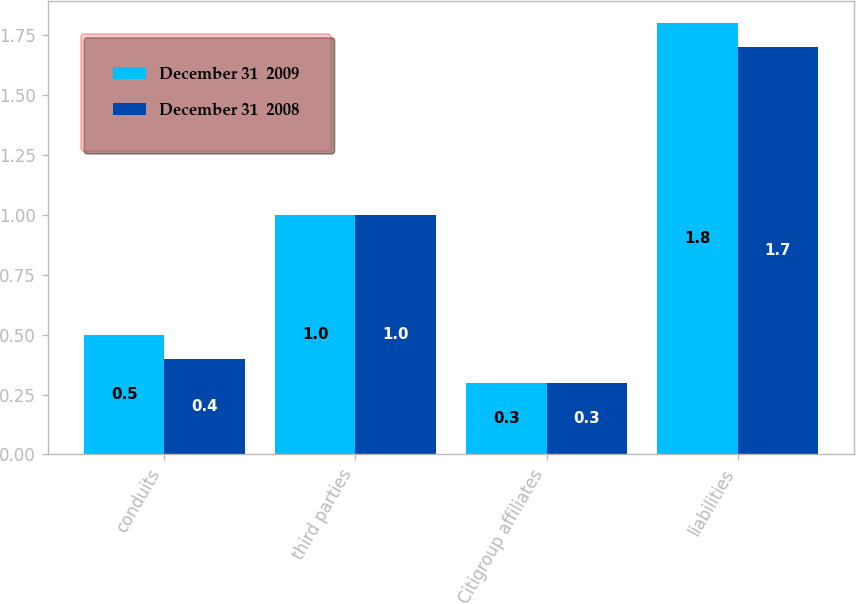Convert chart to OTSL. <chart><loc_0><loc_0><loc_500><loc_500><stacked_bar_chart><ecel><fcel>conduits<fcel>third parties<fcel>Citigroup affiliates<fcel>liabilities<nl><fcel>December 31  2009<fcel>0.5<fcel>1<fcel>0.3<fcel>1.8<nl><fcel>December 31  2008<fcel>0.4<fcel>1<fcel>0.3<fcel>1.7<nl></chart> 